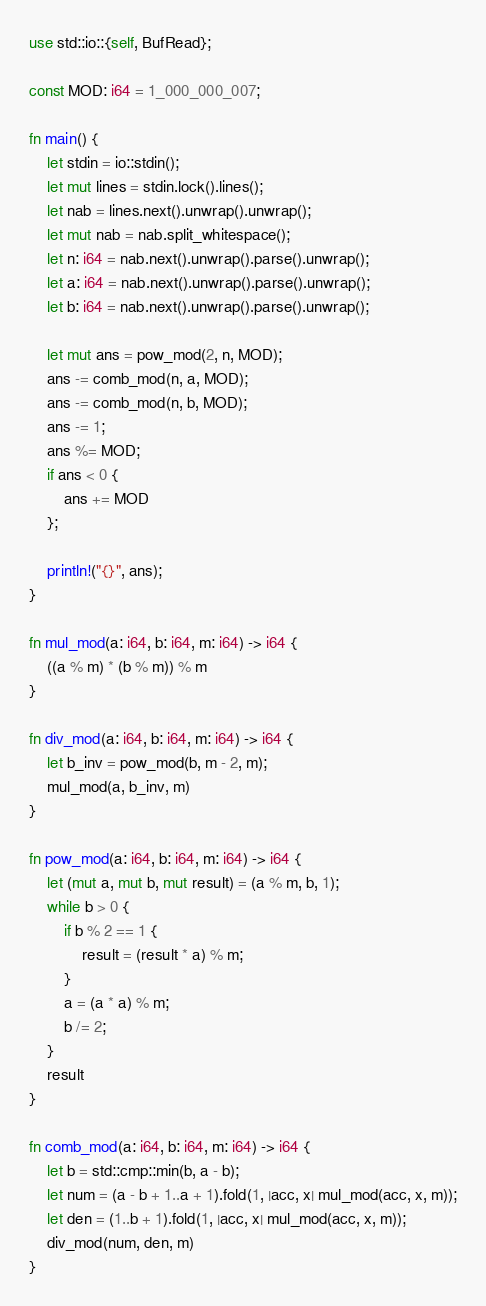<code> <loc_0><loc_0><loc_500><loc_500><_Rust_>use std::io::{self, BufRead};

const MOD: i64 = 1_000_000_007;

fn main() {
    let stdin = io::stdin();
    let mut lines = stdin.lock().lines();
    let nab = lines.next().unwrap().unwrap();
    let mut nab = nab.split_whitespace();
    let n: i64 = nab.next().unwrap().parse().unwrap();
    let a: i64 = nab.next().unwrap().parse().unwrap();
    let b: i64 = nab.next().unwrap().parse().unwrap();

    let mut ans = pow_mod(2, n, MOD);
    ans -= comb_mod(n, a, MOD);
    ans -= comb_mod(n, b, MOD);
    ans -= 1;
    ans %= MOD;
    if ans < 0 {
        ans += MOD
    };

    println!("{}", ans);
}

fn mul_mod(a: i64, b: i64, m: i64) -> i64 {
    ((a % m) * (b % m)) % m
}

fn div_mod(a: i64, b: i64, m: i64) -> i64 {
    let b_inv = pow_mod(b, m - 2, m);
    mul_mod(a, b_inv, m)
}

fn pow_mod(a: i64, b: i64, m: i64) -> i64 {
    let (mut a, mut b, mut result) = (a % m, b, 1);
    while b > 0 {
        if b % 2 == 1 {
            result = (result * a) % m;
        }
        a = (a * a) % m;
        b /= 2;
    }
    result
}

fn comb_mod(a: i64, b: i64, m: i64) -> i64 {
    let b = std::cmp::min(b, a - b);
    let num = (a - b + 1..a + 1).fold(1, |acc, x| mul_mod(acc, x, m));
    let den = (1..b + 1).fold(1, |acc, x| mul_mod(acc, x, m));
    div_mod(num, den, m)
}
</code> 